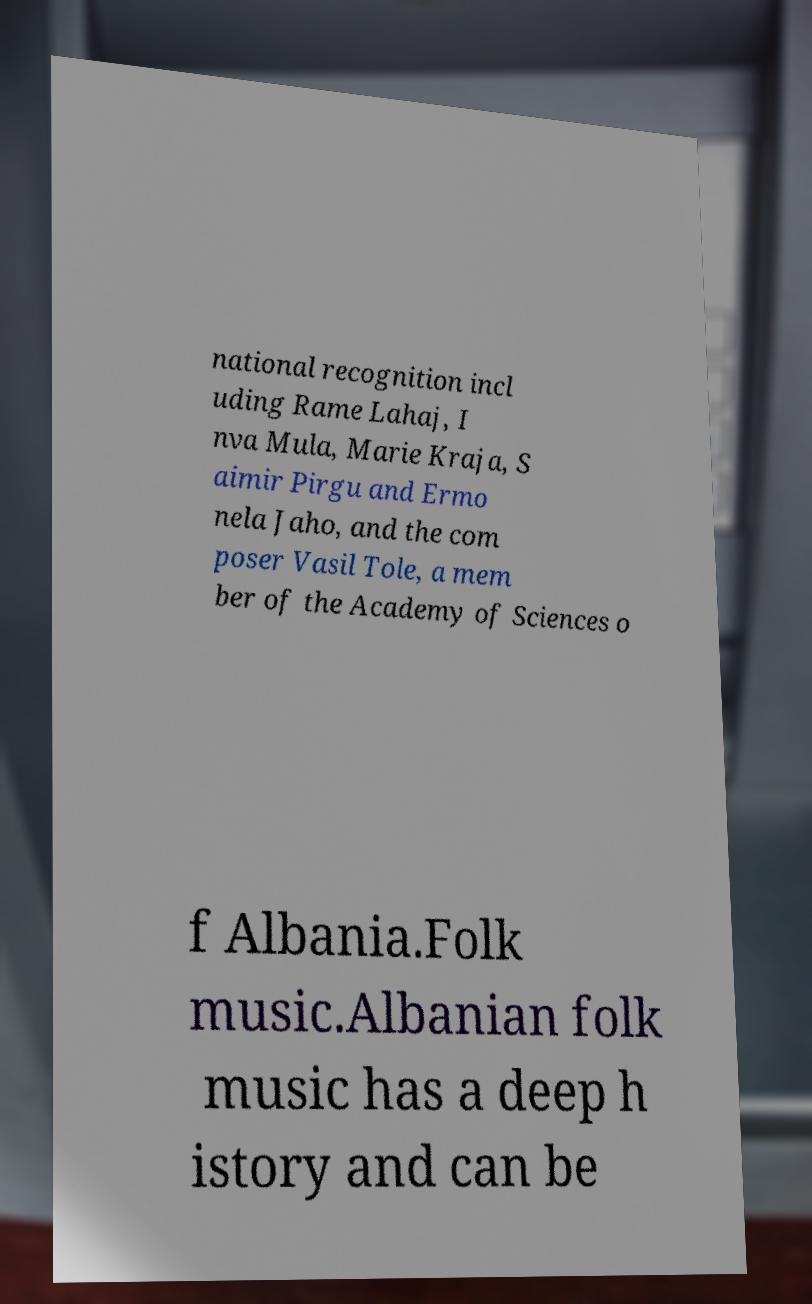Please identify and transcribe the text found in this image. national recognition incl uding Rame Lahaj, I nva Mula, Marie Kraja, S aimir Pirgu and Ermo nela Jaho, and the com poser Vasil Tole, a mem ber of the Academy of Sciences o f Albania.Folk music.Albanian folk music has a deep h istory and can be 